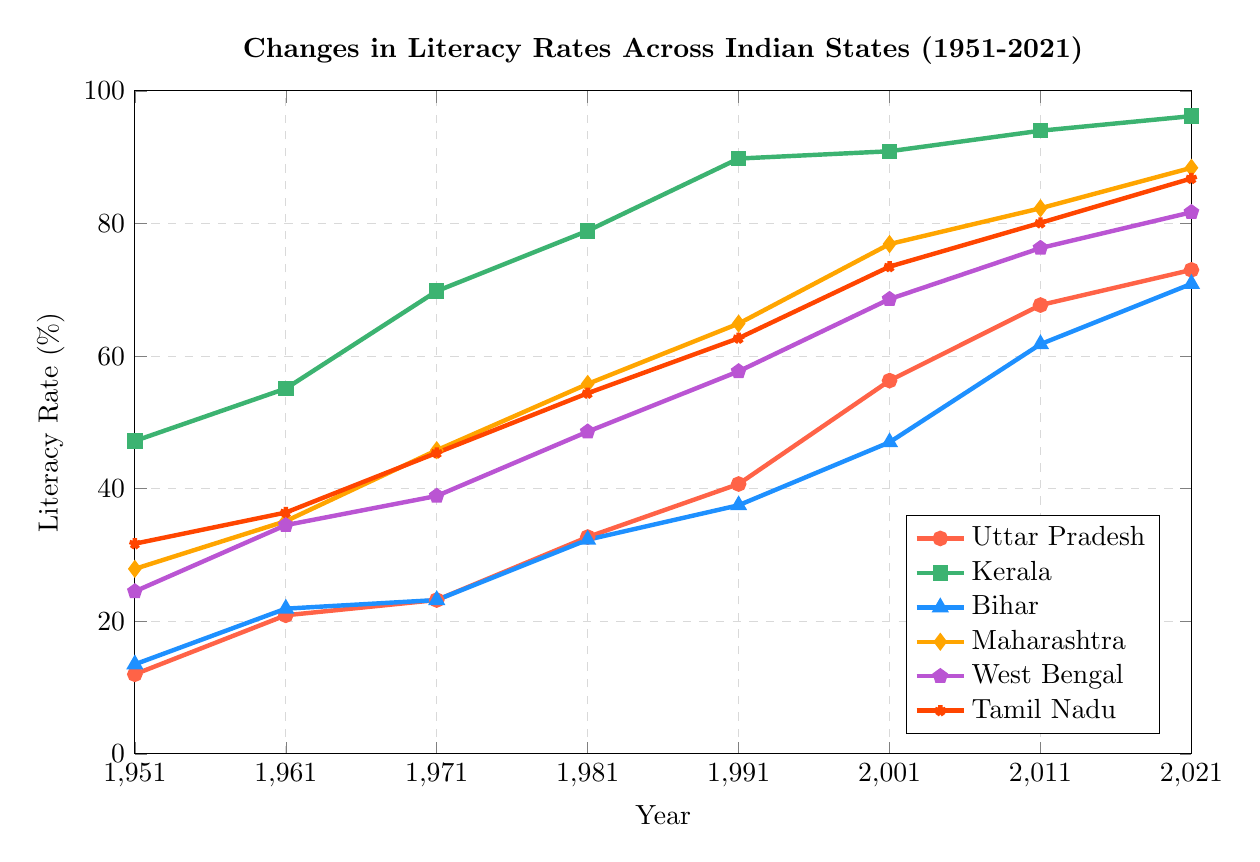How has Kerala's literacy rate changed from 1951 to 2021? To answer this, locate the data points for Kerala in 1951 and 2021 in the figure. Note that the literacy rates are 47.2% in 1951 and 96.2% in 2021. The change is 96.2% - 47.2%.
Answer: 49% Which state showed the largest increase in literacy rate between 1951 and 2021? Identify the literacy rates for all states in both 1951 and 2021, and calculate the change for each state. The changes are: Uttar Pradesh (73.0 - 12.0 = 61%), Kerala (96.2 - 47.2 = 49%), Bihar (70.9 - 13.5 = 57.4%), Maharashtra (88.4 - 27.9 = 60.5%), West Bengal (81.7 - 24.5 = 57.2%), Tamil Nadu (86.8 - 31.7 = 55.1%). The largest increase is in Uttar Pradesh with 61%.
Answer: Uttar Pradesh What is the average literacy rate of Maharashtra across the years provided? Sum the literacy rates of Maharashtra for all the given years and divide by the number of years. (27.9 + 35.1 + 45.8 + 55.8 + 64.9 + 76.9 + 82.3 + 88.4) / 8 = 477.1 / 8
Answer: 59.64% Compare the literacy rates of Bihar and Tamil Nadu in 1991. Which state had a higher rate and by how much? Look at the literacy rates for Bihar and Tamil Nadu in 1991. Bihar is at 37.5% and Tamil Nadu is at 62.7%. Tamil Nadu had a higher rate by 62.7% - 37.5%.
Answer: Tamil Nadu by 25.2% Which state had the highest literacy rate in 1971? Observe the literacy rates for all states in 1971: Uttar Pradesh (23.2%), Kerala (69.8%), Bihar (23.2%), Maharashtra (45.8%), West Bengal (38.9%), Tamil Nadu (45.4%). Kerala had the highest rate at 69.8%.
Answer: Kerala Compare the trend in literacy rate growth for Uttar Pradesh and West Bengal from 1951 to 2021. Which state showed more consistent growth? Observe the literacy rate trend lines for both states. Uttar Pradesh starts at 12.0% in 1951 and reaches 73.0% in 2021 with consistent growth. West Bengal starts at 24.5% in 1951 and reaches 81.7% in 2021. Calculate the rate of increase across each decade for both for more detail. Both show consistent growth, but West Bengal has a larger overall increase.
Answer: Both are consistent, but West Bengal had a larger increase Which state had the least improvement in literacy rate from 1951 to 2021? Identify the literacy rates for all states in 1951 and 2021, and calculate the changes. The smallest improvement comes from Kerala (49.0%), compared to other states.
Answer: Kerala What is the difference in the literacy rate of Tamil Nadu between 1981 and 2021? Find the literacy rates for Tamil Nadu in 1981 and 2021. Calculate the difference: 86.8% - 54.4%.
Answer: 32.4% How does the 2021 literacy rate of Uttar Pradesh compare to the 2001 literacy rate of Maharashtra? Look at the literacy rate of Uttar Pradesh in 2021 (73.0%) and Maharashtra in 2001 (76.9%). Maharashtra in 2001 had a higher rate.
Answer: Maharashtra in 2001 by 3.9% Which state had the sharpest increase in literacy rate during the 1991 to 2001 decade? Calculate the literacy rate increase for each state between 1991 and 2001. The sharpest increase is in Bihar (47.0% - 37.5% = 9.5%). Uttar Pradesh (56.3% - 40.7% = 15.6%), Kerala (90.9% - 89.8% = 1.1%), Maharashtra (76.9% - 64.9% = 12%), West Bengal (68.6% - 57.7% = 10.9%), Tamil Nadu (73.5% - 62.7% = 10.8%).
Answer: Uttar Pradesh 